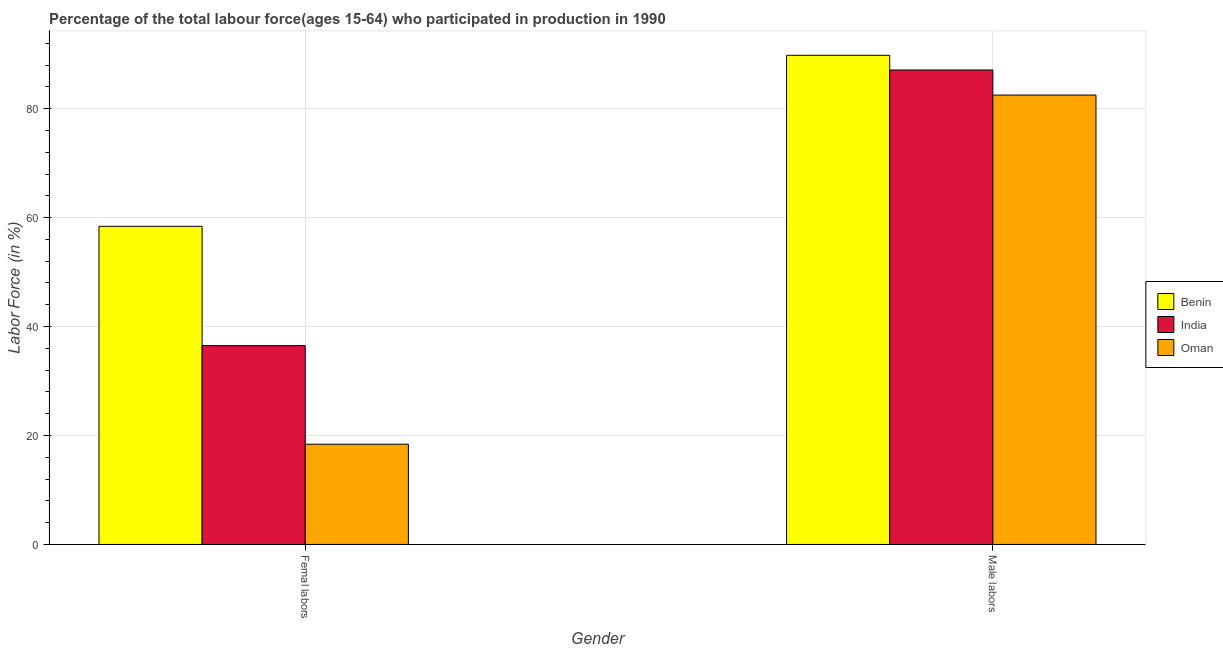How many groups of bars are there?
Your response must be concise. 2. Are the number of bars per tick equal to the number of legend labels?
Provide a short and direct response. Yes. How many bars are there on the 2nd tick from the left?
Provide a succinct answer. 3. What is the label of the 1st group of bars from the left?
Provide a succinct answer. Femal labors. What is the percentage of male labour force in India?
Offer a very short reply. 87.1. Across all countries, what is the maximum percentage of female labor force?
Keep it short and to the point. 58.4. Across all countries, what is the minimum percentage of male labour force?
Make the answer very short. 82.5. In which country was the percentage of male labour force maximum?
Offer a very short reply. Benin. In which country was the percentage of female labor force minimum?
Ensure brevity in your answer.  Oman. What is the total percentage of female labor force in the graph?
Your answer should be very brief. 113.3. What is the difference between the percentage of male labour force in India and that in Oman?
Provide a succinct answer. 4.6. What is the difference between the percentage of male labour force in India and the percentage of female labor force in Benin?
Keep it short and to the point. 28.7. What is the average percentage of male labour force per country?
Your response must be concise. 86.47. What is the difference between the percentage of female labor force and percentage of male labour force in Benin?
Provide a succinct answer. -31.4. What is the ratio of the percentage of female labor force in Benin to that in Oman?
Offer a terse response. 3.17. Is the percentage of female labor force in Benin less than that in Oman?
Give a very brief answer. No. What does the 1st bar from the left in Femal labors represents?
Provide a succinct answer. Benin. What does the 3rd bar from the right in Male labors represents?
Keep it short and to the point. Benin. How many bars are there?
Provide a succinct answer. 6. Are all the bars in the graph horizontal?
Ensure brevity in your answer.  No. Does the graph contain grids?
Ensure brevity in your answer.  Yes. How many legend labels are there?
Provide a succinct answer. 3. How are the legend labels stacked?
Your answer should be very brief. Vertical. What is the title of the graph?
Offer a terse response. Percentage of the total labour force(ages 15-64) who participated in production in 1990. Does "Least developed countries" appear as one of the legend labels in the graph?
Your answer should be very brief. No. What is the Labor Force (in %) in Benin in Femal labors?
Provide a succinct answer. 58.4. What is the Labor Force (in %) in India in Femal labors?
Provide a succinct answer. 36.5. What is the Labor Force (in %) in Oman in Femal labors?
Your answer should be very brief. 18.4. What is the Labor Force (in %) of Benin in Male labors?
Make the answer very short. 89.8. What is the Labor Force (in %) of India in Male labors?
Offer a very short reply. 87.1. What is the Labor Force (in %) in Oman in Male labors?
Provide a succinct answer. 82.5. Across all Gender, what is the maximum Labor Force (in %) in Benin?
Provide a succinct answer. 89.8. Across all Gender, what is the maximum Labor Force (in %) of India?
Give a very brief answer. 87.1. Across all Gender, what is the maximum Labor Force (in %) of Oman?
Keep it short and to the point. 82.5. Across all Gender, what is the minimum Labor Force (in %) in Benin?
Give a very brief answer. 58.4. Across all Gender, what is the minimum Labor Force (in %) in India?
Your response must be concise. 36.5. Across all Gender, what is the minimum Labor Force (in %) in Oman?
Offer a terse response. 18.4. What is the total Labor Force (in %) in Benin in the graph?
Provide a short and direct response. 148.2. What is the total Labor Force (in %) in India in the graph?
Provide a short and direct response. 123.6. What is the total Labor Force (in %) of Oman in the graph?
Offer a very short reply. 100.9. What is the difference between the Labor Force (in %) of Benin in Femal labors and that in Male labors?
Give a very brief answer. -31.4. What is the difference between the Labor Force (in %) in India in Femal labors and that in Male labors?
Provide a short and direct response. -50.6. What is the difference between the Labor Force (in %) in Oman in Femal labors and that in Male labors?
Provide a short and direct response. -64.1. What is the difference between the Labor Force (in %) in Benin in Femal labors and the Labor Force (in %) in India in Male labors?
Offer a terse response. -28.7. What is the difference between the Labor Force (in %) in Benin in Femal labors and the Labor Force (in %) in Oman in Male labors?
Ensure brevity in your answer.  -24.1. What is the difference between the Labor Force (in %) in India in Femal labors and the Labor Force (in %) in Oman in Male labors?
Your answer should be compact. -46. What is the average Labor Force (in %) in Benin per Gender?
Your answer should be very brief. 74.1. What is the average Labor Force (in %) in India per Gender?
Your answer should be very brief. 61.8. What is the average Labor Force (in %) of Oman per Gender?
Provide a short and direct response. 50.45. What is the difference between the Labor Force (in %) of Benin and Labor Force (in %) of India in Femal labors?
Make the answer very short. 21.9. What is the difference between the Labor Force (in %) of Benin and Labor Force (in %) of Oman in Femal labors?
Give a very brief answer. 40. What is the ratio of the Labor Force (in %) of Benin in Femal labors to that in Male labors?
Provide a short and direct response. 0.65. What is the ratio of the Labor Force (in %) of India in Femal labors to that in Male labors?
Offer a very short reply. 0.42. What is the ratio of the Labor Force (in %) of Oman in Femal labors to that in Male labors?
Provide a succinct answer. 0.22. What is the difference between the highest and the second highest Labor Force (in %) of Benin?
Ensure brevity in your answer.  31.4. What is the difference between the highest and the second highest Labor Force (in %) in India?
Provide a succinct answer. 50.6. What is the difference between the highest and the second highest Labor Force (in %) of Oman?
Provide a succinct answer. 64.1. What is the difference between the highest and the lowest Labor Force (in %) of Benin?
Ensure brevity in your answer.  31.4. What is the difference between the highest and the lowest Labor Force (in %) in India?
Provide a short and direct response. 50.6. What is the difference between the highest and the lowest Labor Force (in %) in Oman?
Your response must be concise. 64.1. 